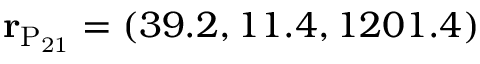<formula> <loc_0><loc_0><loc_500><loc_500>{ r } _ { P _ { 2 1 } } = ( 3 9 . 2 , 1 1 . 4 , 1 2 0 1 . 4 )</formula> 